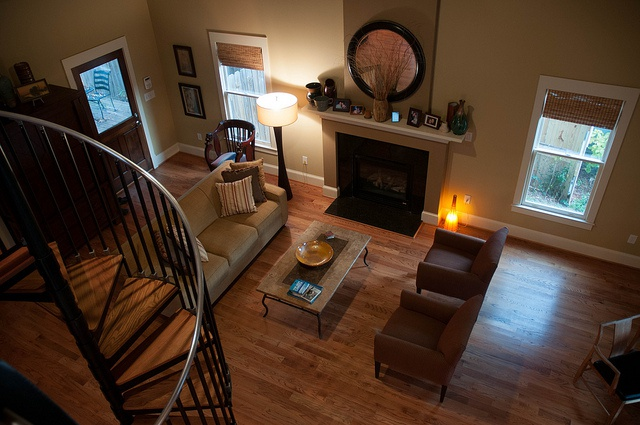Describe the objects in this image and their specific colors. I can see couch in black, maroon, and gray tones, chair in black, maroon, and gray tones, chair in black and gray tones, chair in black, gray, and darkblue tones, and potted plant in black, maroon, and brown tones in this image. 